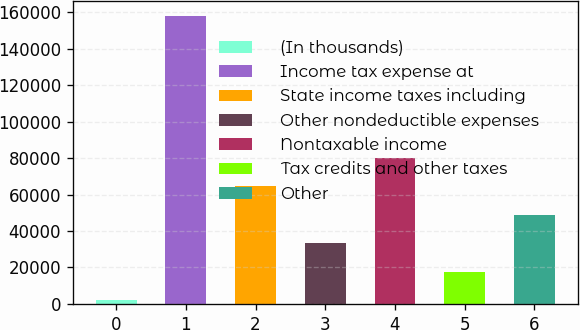Convert chart to OTSL. <chart><loc_0><loc_0><loc_500><loc_500><bar_chart><fcel>(In thousands)<fcel>Income tax expense at<fcel>State income taxes including<fcel>Other nondeductible expenses<fcel>Nontaxable income<fcel>Tax credits and other taxes<fcel>Other<nl><fcel>2015<fcel>158151<fcel>64469.4<fcel>33242.2<fcel>80083<fcel>17628.6<fcel>48855.8<nl></chart> 